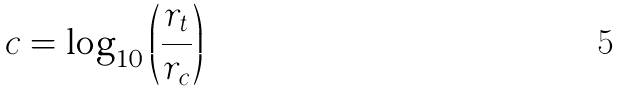<formula> <loc_0><loc_0><loc_500><loc_500>c = \log _ { 1 0 } \left ( \frac { r _ { t } } { r _ { c } } \right )</formula> 